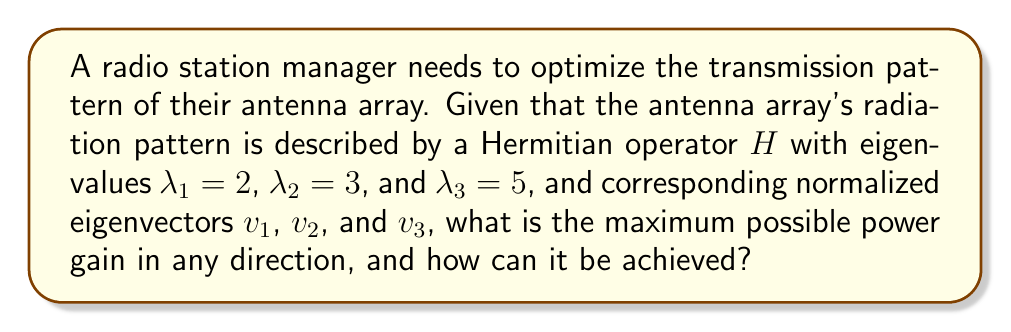Solve this math problem. To solve this problem, we'll apply the spectral theorem and its implications for radio wave propagation:

1) The spectral theorem states that for a Hermitian operator $H$, there exists an orthonormal basis of eigenvectors that diagonalizes the operator.

2) In the context of antenna arrays, the Hermitian operator $H$ represents the radiation pattern, with eigenvalues corresponding to power gains in principal directions.

3) The maximum power gain is equal to the largest eigenvalue of $H$.

4) From the given information, the largest eigenvalue is $\lambda_3 = 5$.

5) To achieve this maximum gain, the antenna array should be configured to transmit in the direction corresponding to the eigenvector $v_3$.

6) Mathematically, this can be expressed as:

   $$H = \lambda_1 v_1 v_1^* + \lambda_2 v_2 v_2^* + \lambda_3 v_3 v_3^*$$

   where $v_i^*$ denotes the conjugate transpose of $v_i$.

7) The optimal transmission vector is $v_3$, which will result in a power gain of 5.

Therefore, the maximum possible power gain is 5, achieved by aligning the antenna array's transmission pattern with the eigenvector $v_3$.
Answer: 5, achieved by transmitting in the direction of eigenvector $v_3$. 